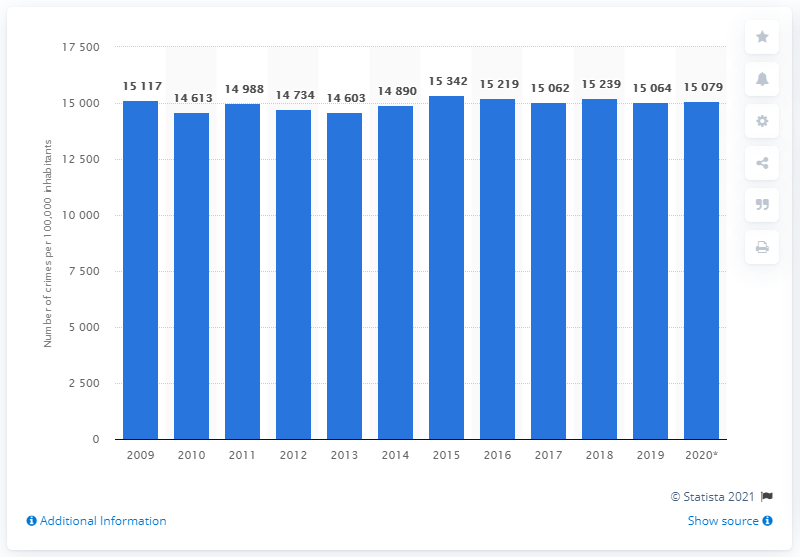Specify some key components in this picture. In 2015, Sweden experienced the highest crime rate among all the years studied. 